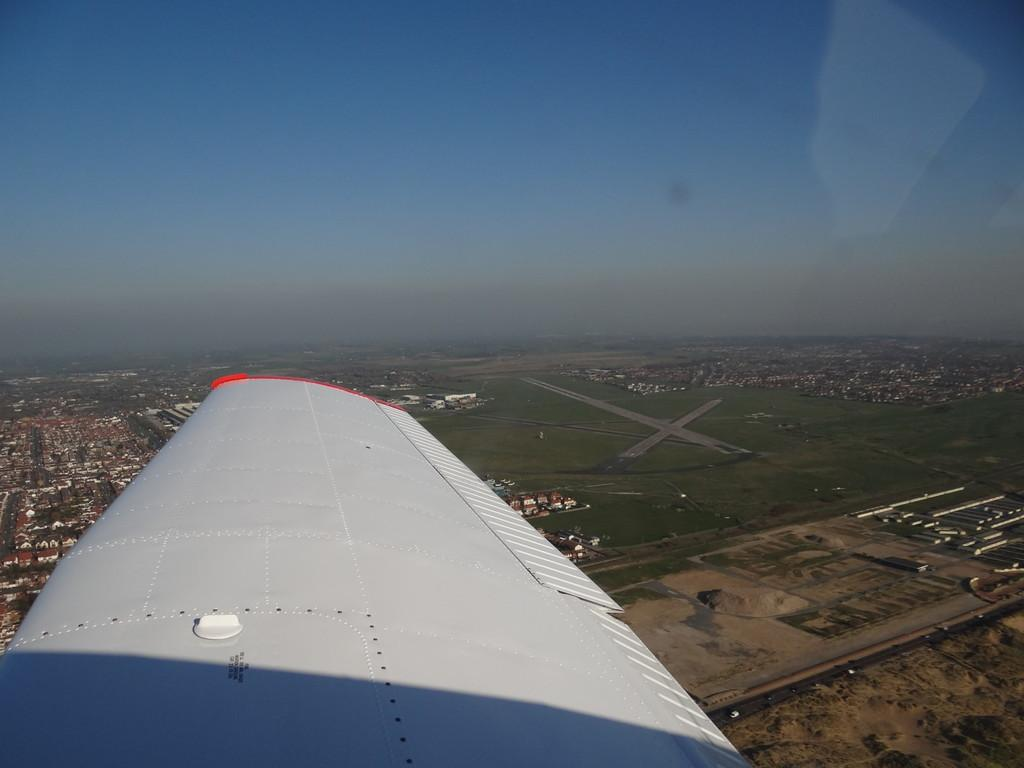What is the white object in the air? There is a white thing in the air, but it is not clear what it is from the provided facts. What type of landscape can be seen on the floor? Fields, houses, buildings, plants, and trees are visible on the floor. Can you describe the vegetation present on the floor? There are plants and trees on the floor. How many birds are flying in the sky in the image? There is no mention of birds in the image, so we cannot determine the number of birds present. What time of day is it in the image based on the position of the sun? There is no mention of the sun in the image, so we cannot determine the time of day based on its position. 